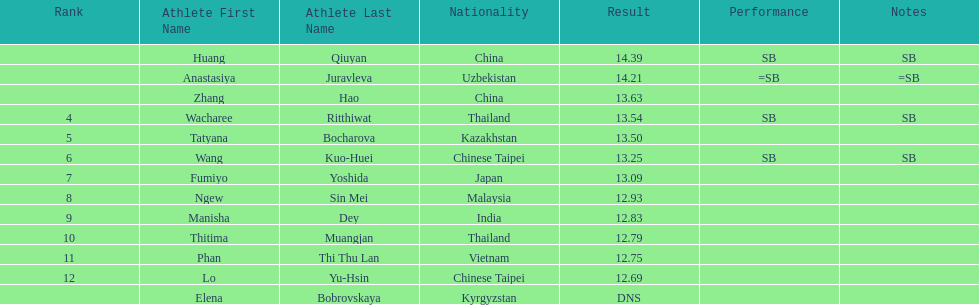How many competitors had less than 13.00 points? 6. 